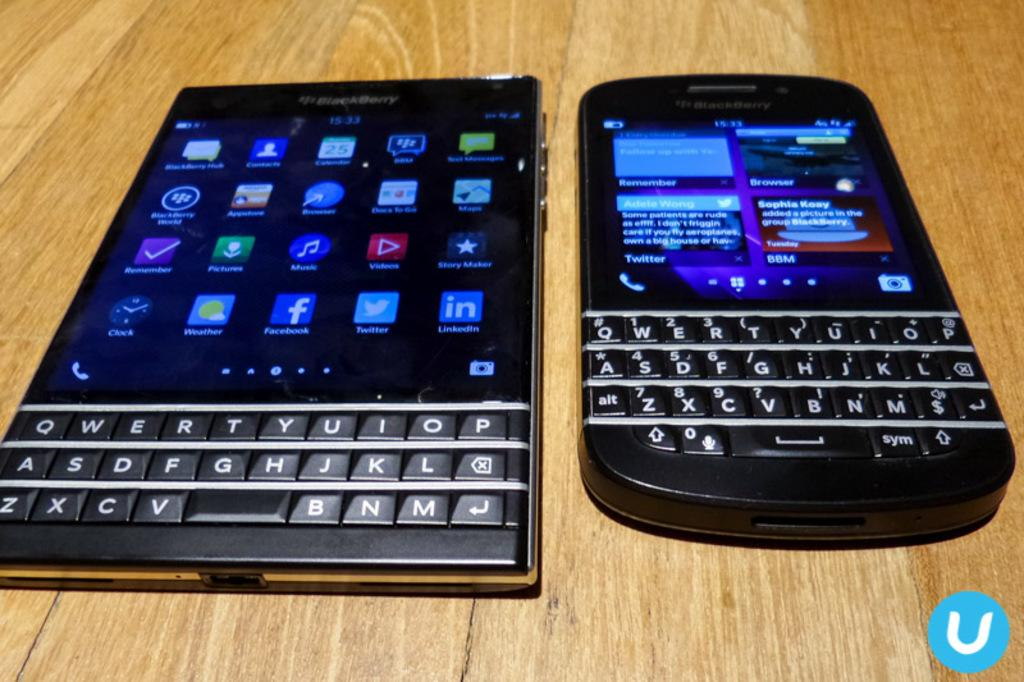<image>
Create a compact narrative representing the image presented. Two devices, made by Blackberry, sit side by side. 